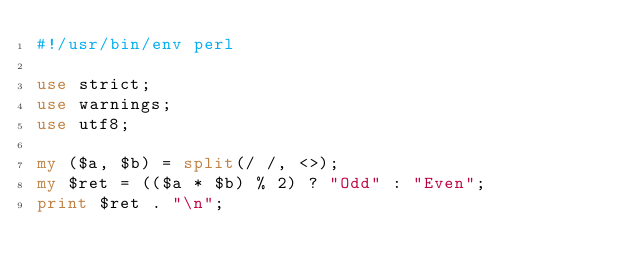<code> <loc_0><loc_0><loc_500><loc_500><_Perl_>#!/usr/bin/env perl

use strict;
use warnings;
use utf8;

my ($a, $b) = split(/ /, <>);
my $ret = (($a * $b) % 2) ? "Odd" : "Even";
print $ret . "\n";
</code> 